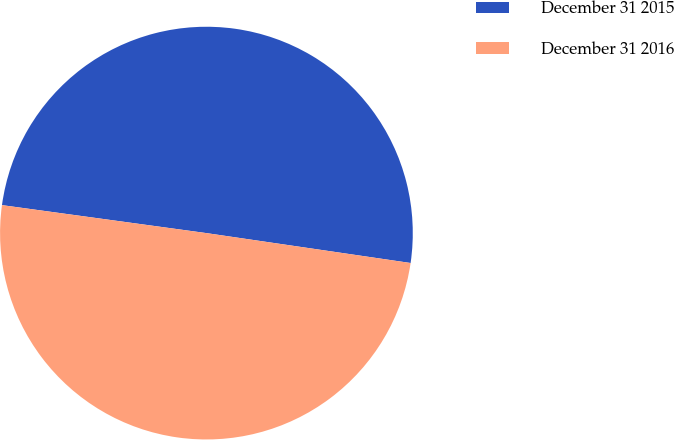Convert chart. <chart><loc_0><loc_0><loc_500><loc_500><pie_chart><fcel>December 31 2015<fcel>December 31 2016<nl><fcel>50.15%<fcel>49.85%<nl></chart> 